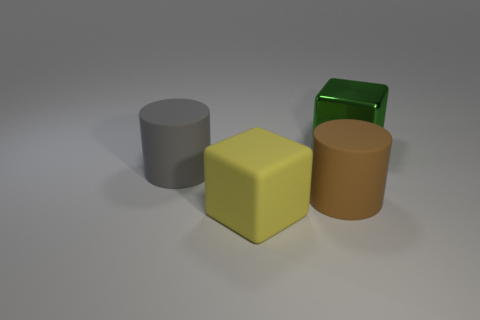What color is the big rubber object that is both behind the yellow object and in front of the gray matte object? brown 